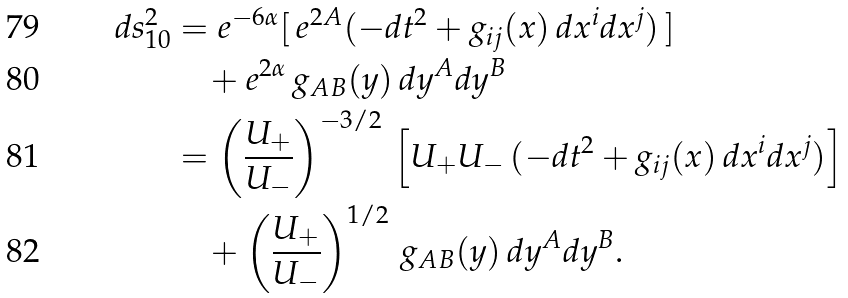Convert formula to latex. <formula><loc_0><loc_0><loc_500><loc_500>d s _ { 1 0 } ^ { 2 } & = e ^ { - 6 \alpha } [ \, e ^ { 2 A } ( - d t ^ { 2 } + g _ { i j } ( x ) \, d x ^ { i } d x ^ { j } ) \, ] \\ & \quad + e ^ { 2 \alpha } \, g _ { A B } ( y ) \, d y ^ { A } d y ^ { B } \\ & = \left ( \frac { U _ { + } } { U _ { - } } \right ) ^ { - 3 / 2 } \, \left [ U _ { + } U _ { - } \, ( - d t ^ { 2 } + g _ { i j } ( x ) \, d x ^ { i } d x ^ { j } ) \right ] \\ & \quad + \left ( \frac { U _ { + } } { U _ { - } } \right ) ^ { 1 / 2 } \, g _ { A B } ( y ) \, d y ^ { A } d y ^ { B } .</formula> 